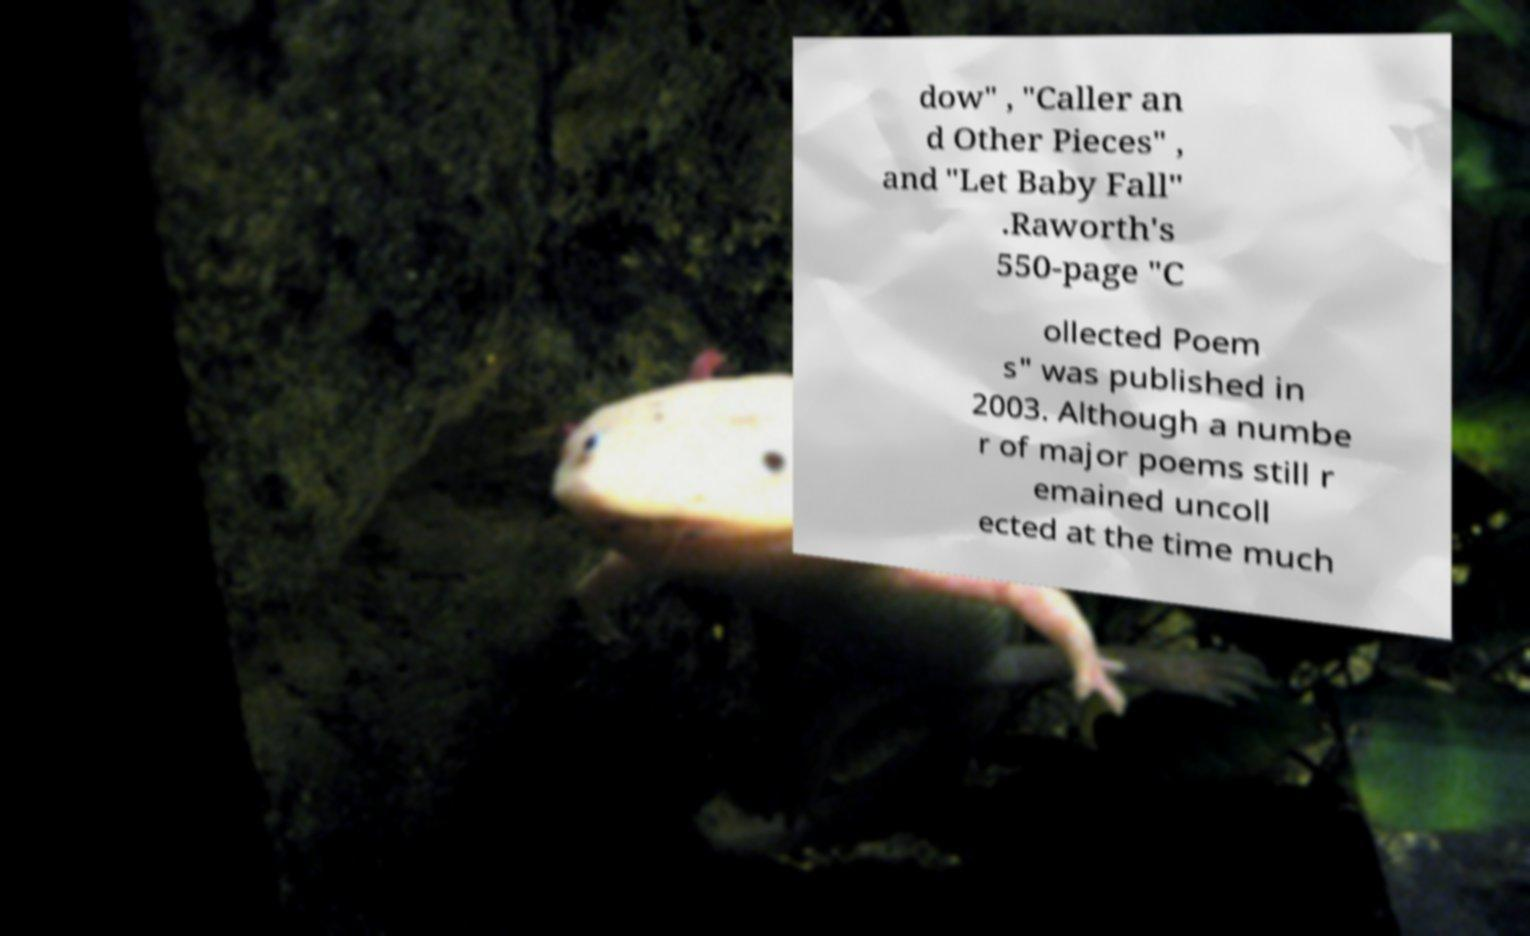I need the written content from this picture converted into text. Can you do that? dow" , "Caller an d Other Pieces" , and "Let Baby Fall" .Raworth's 550-page "C ollected Poem s" was published in 2003. Although a numbe r of major poems still r emained uncoll ected at the time much 